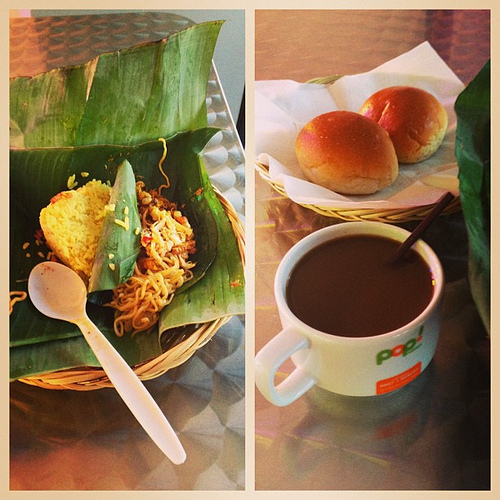Imagine you're creating an ad for this dining set-up, what would be your tagline? Savor the Simplicity: Escape the Everyday with Our Homestyle Delights! 